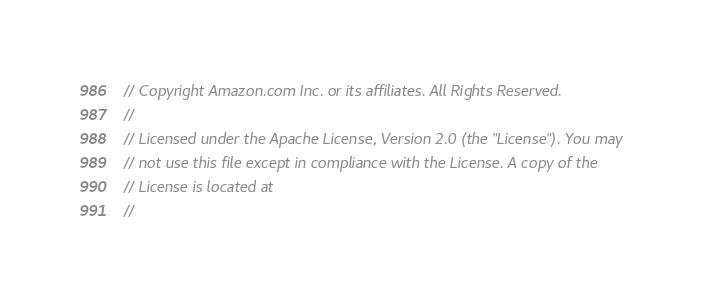Convert code to text. <code><loc_0><loc_0><loc_500><loc_500><_Go_>// Copyright Amazon.com Inc. or its affiliates. All Rights Reserved.
//
// Licensed under the Apache License, Version 2.0 (the "License"). You may
// not use this file except in compliance with the License. A copy of the
// License is located at
//</code> 